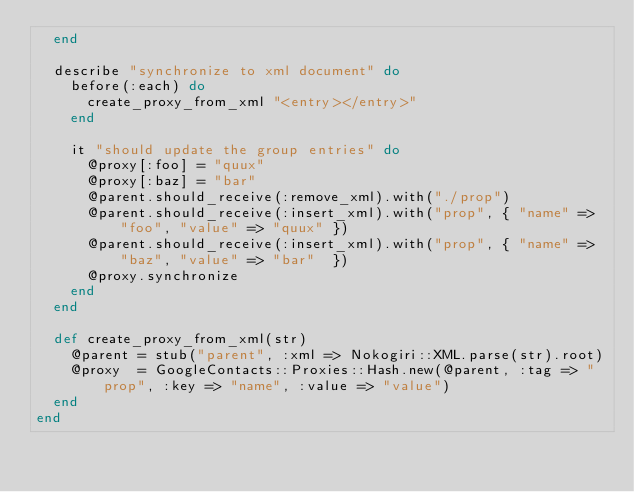<code> <loc_0><loc_0><loc_500><loc_500><_Ruby_>  end

  describe "synchronize to xml document" do
    before(:each) do
      create_proxy_from_xml "<entry></entry>"
    end

    it "should update the group entries" do
      @proxy[:foo] = "quux"
      @proxy[:baz] = "bar"
      @parent.should_receive(:remove_xml).with("./prop")
      @parent.should_receive(:insert_xml).with("prop", { "name" => "foo", "value" => "quux" })
      @parent.should_receive(:insert_xml).with("prop", { "name" => "baz", "value" => "bar"  })
      @proxy.synchronize
    end
  end

  def create_proxy_from_xml(str)
    @parent = stub("parent", :xml => Nokogiri::XML.parse(str).root)
    @proxy  = GoogleContacts::Proxies::Hash.new(@parent, :tag => "prop", :key => "name", :value => "value")
  end
end
</code> 